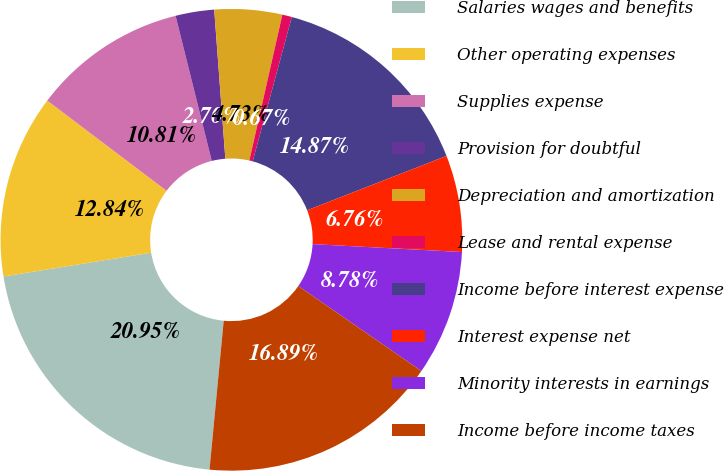Convert chart. <chart><loc_0><loc_0><loc_500><loc_500><pie_chart><fcel>Salaries wages and benefits<fcel>Other operating expenses<fcel>Supplies expense<fcel>Provision for doubtful<fcel>Depreciation and amortization<fcel>Lease and rental expense<fcel>Income before interest expense<fcel>Interest expense net<fcel>Minority interests in earnings<fcel>Income before income taxes<nl><fcel>20.95%<fcel>12.84%<fcel>10.81%<fcel>2.7%<fcel>4.73%<fcel>0.67%<fcel>14.87%<fcel>6.76%<fcel>8.78%<fcel>16.89%<nl></chart> 